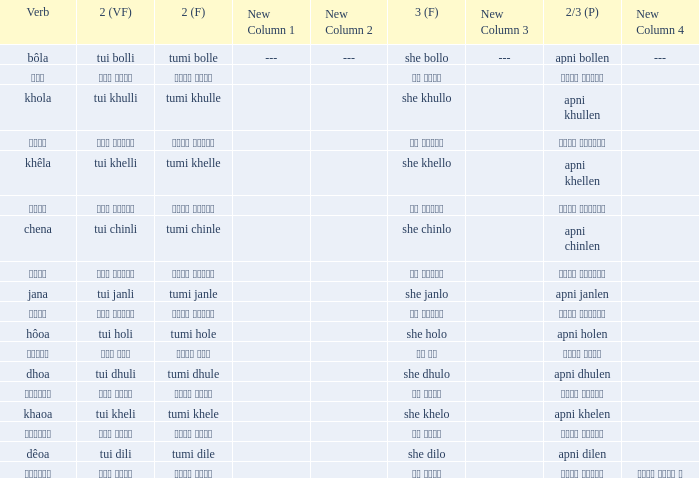What is the verb for তুমি খেলে? খাওয়া. 